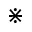Convert formula to latex. <formula><loc_0><loc_0><loc_500><loc_500>\divideontimes</formula> 